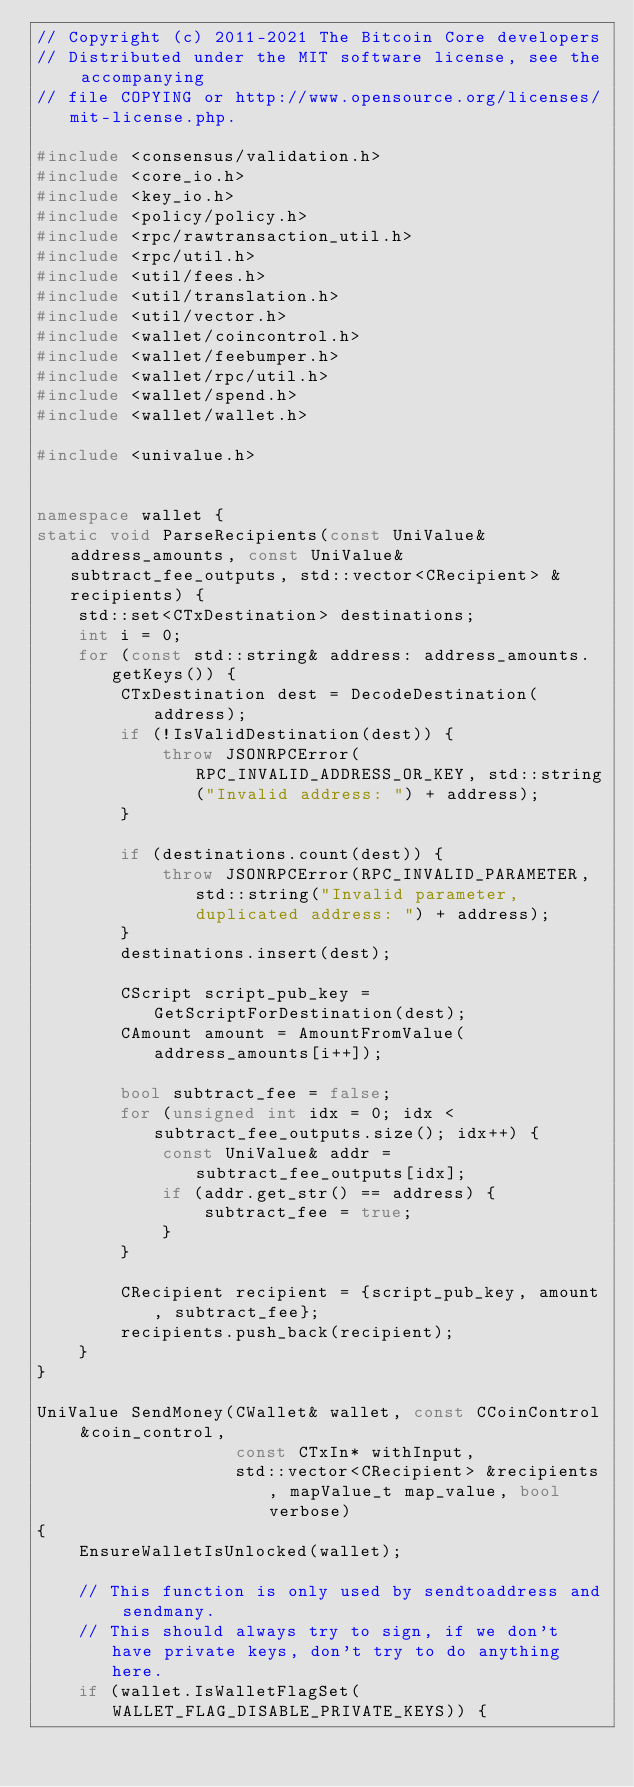Convert code to text. <code><loc_0><loc_0><loc_500><loc_500><_C++_>// Copyright (c) 2011-2021 The Bitcoin Core developers
// Distributed under the MIT software license, see the accompanying
// file COPYING or http://www.opensource.org/licenses/mit-license.php.

#include <consensus/validation.h>
#include <core_io.h>
#include <key_io.h>
#include <policy/policy.h>
#include <rpc/rawtransaction_util.h>
#include <rpc/util.h>
#include <util/fees.h>
#include <util/translation.h>
#include <util/vector.h>
#include <wallet/coincontrol.h>
#include <wallet/feebumper.h>
#include <wallet/rpc/util.h>
#include <wallet/spend.h>
#include <wallet/wallet.h>

#include <univalue.h>


namespace wallet {
static void ParseRecipients(const UniValue& address_amounts, const UniValue& subtract_fee_outputs, std::vector<CRecipient> &recipients) {
    std::set<CTxDestination> destinations;
    int i = 0;
    for (const std::string& address: address_amounts.getKeys()) {
        CTxDestination dest = DecodeDestination(address);
        if (!IsValidDestination(dest)) {
            throw JSONRPCError(RPC_INVALID_ADDRESS_OR_KEY, std::string("Invalid address: ") + address);
        }

        if (destinations.count(dest)) {
            throw JSONRPCError(RPC_INVALID_PARAMETER, std::string("Invalid parameter, duplicated address: ") + address);
        }
        destinations.insert(dest);

        CScript script_pub_key = GetScriptForDestination(dest);
        CAmount amount = AmountFromValue(address_amounts[i++]);

        bool subtract_fee = false;
        for (unsigned int idx = 0; idx < subtract_fee_outputs.size(); idx++) {
            const UniValue& addr = subtract_fee_outputs[idx];
            if (addr.get_str() == address) {
                subtract_fee = true;
            }
        }

        CRecipient recipient = {script_pub_key, amount, subtract_fee};
        recipients.push_back(recipient);
    }
}

UniValue SendMoney(CWallet& wallet, const CCoinControl &coin_control,
                   const CTxIn* withInput,
                   std::vector<CRecipient> &recipients, mapValue_t map_value, bool verbose)
{
    EnsureWalletIsUnlocked(wallet);

    // This function is only used by sendtoaddress and sendmany.
    // This should always try to sign, if we don't have private keys, don't try to do anything here.
    if (wallet.IsWalletFlagSet(WALLET_FLAG_DISABLE_PRIVATE_KEYS)) {</code> 